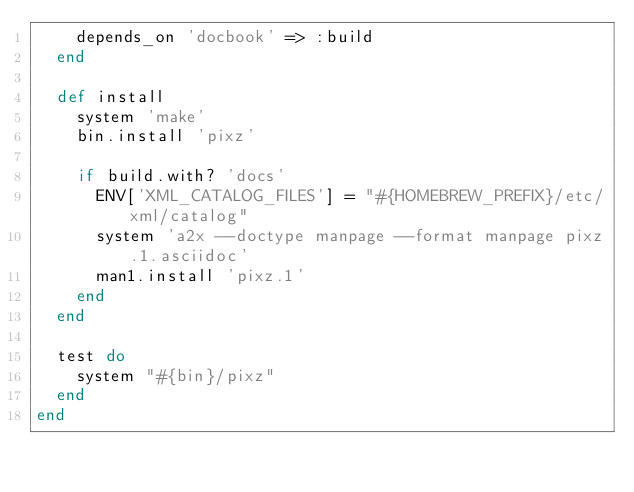Convert code to text. <code><loc_0><loc_0><loc_500><loc_500><_Ruby_>    depends_on 'docbook' => :build
  end

  def install
    system 'make'
    bin.install 'pixz'

    if build.with? 'docs'
      ENV['XML_CATALOG_FILES'] = "#{HOMEBREW_PREFIX}/etc/xml/catalog"
      system 'a2x --doctype manpage --format manpage pixz.1.asciidoc'
      man1.install 'pixz.1'
    end
  end

  test do
    system "#{bin}/pixz"
  end
end
</code> 